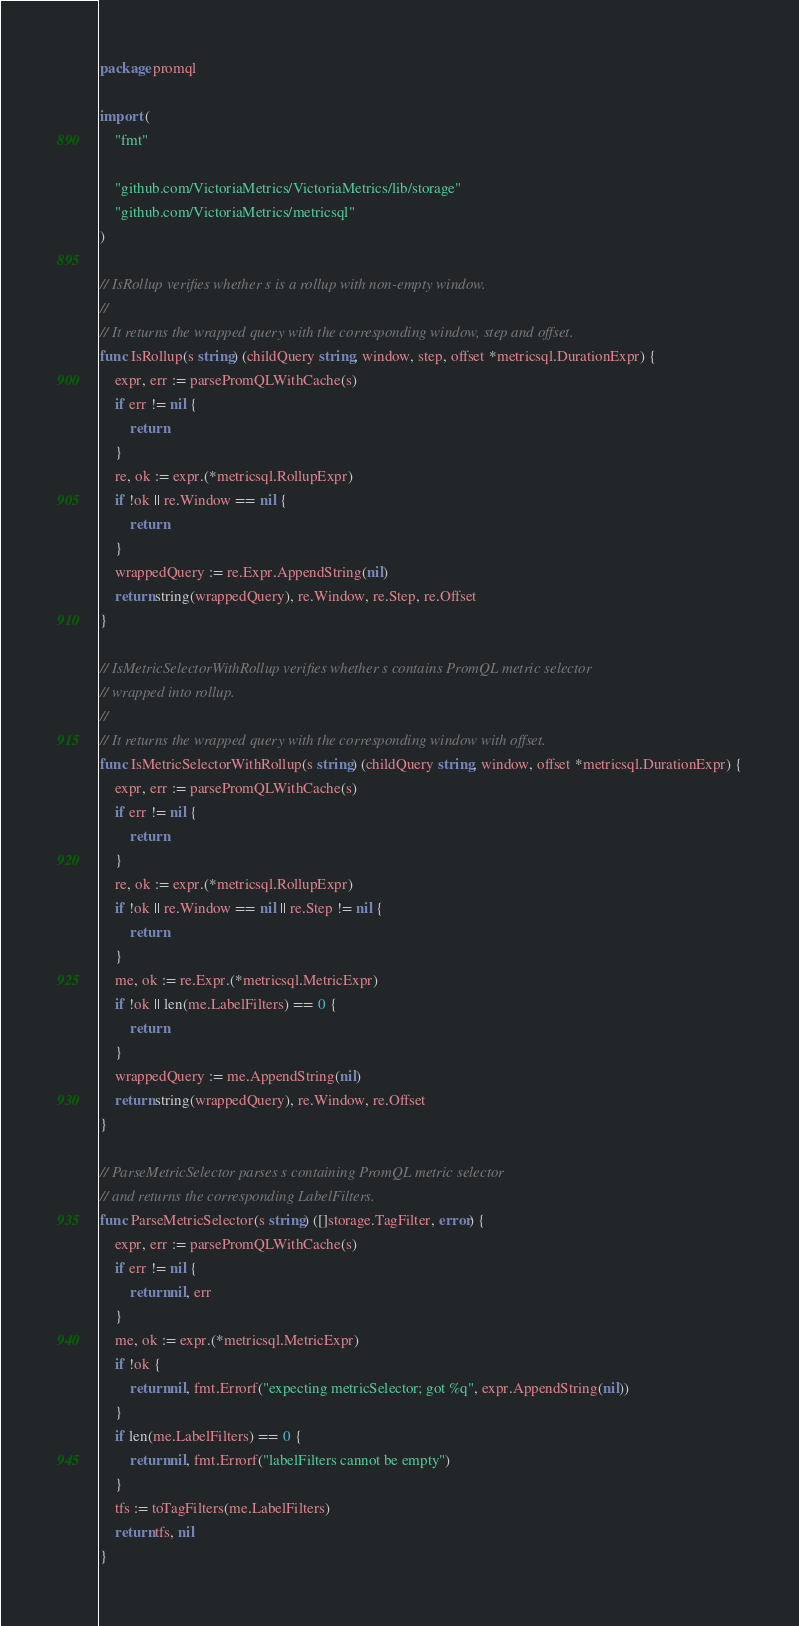<code> <loc_0><loc_0><loc_500><loc_500><_Go_>package promql

import (
	"fmt"

	"github.com/VictoriaMetrics/VictoriaMetrics/lib/storage"
	"github.com/VictoriaMetrics/metricsql"
)

// IsRollup verifies whether s is a rollup with non-empty window.
//
// It returns the wrapped query with the corresponding window, step and offset.
func IsRollup(s string) (childQuery string, window, step, offset *metricsql.DurationExpr) {
	expr, err := parsePromQLWithCache(s)
	if err != nil {
		return
	}
	re, ok := expr.(*metricsql.RollupExpr)
	if !ok || re.Window == nil {
		return
	}
	wrappedQuery := re.Expr.AppendString(nil)
	return string(wrappedQuery), re.Window, re.Step, re.Offset
}

// IsMetricSelectorWithRollup verifies whether s contains PromQL metric selector
// wrapped into rollup.
//
// It returns the wrapped query with the corresponding window with offset.
func IsMetricSelectorWithRollup(s string) (childQuery string, window, offset *metricsql.DurationExpr) {
	expr, err := parsePromQLWithCache(s)
	if err != nil {
		return
	}
	re, ok := expr.(*metricsql.RollupExpr)
	if !ok || re.Window == nil || re.Step != nil {
		return
	}
	me, ok := re.Expr.(*metricsql.MetricExpr)
	if !ok || len(me.LabelFilters) == 0 {
		return
	}
	wrappedQuery := me.AppendString(nil)
	return string(wrappedQuery), re.Window, re.Offset
}

// ParseMetricSelector parses s containing PromQL metric selector
// and returns the corresponding LabelFilters.
func ParseMetricSelector(s string) ([]storage.TagFilter, error) {
	expr, err := parsePromQLWithCache(s)
	if err != nil {
		return nil, err
	}
	me, ok := expr.(*metricsql.MetricExpr)
	if !ok {
		return nil, fmt.Errorf("expecting metricSelector; got %q", expr.AppendString(nil))
	}
	if len(me.LabelFilters) == 0 {
		return nil, fmt.Errorf("labelFilters cannot be empty")
	}
	tfs := toTagFilters(me.LabelFilters)
	return tfs, nil
}
</code> 